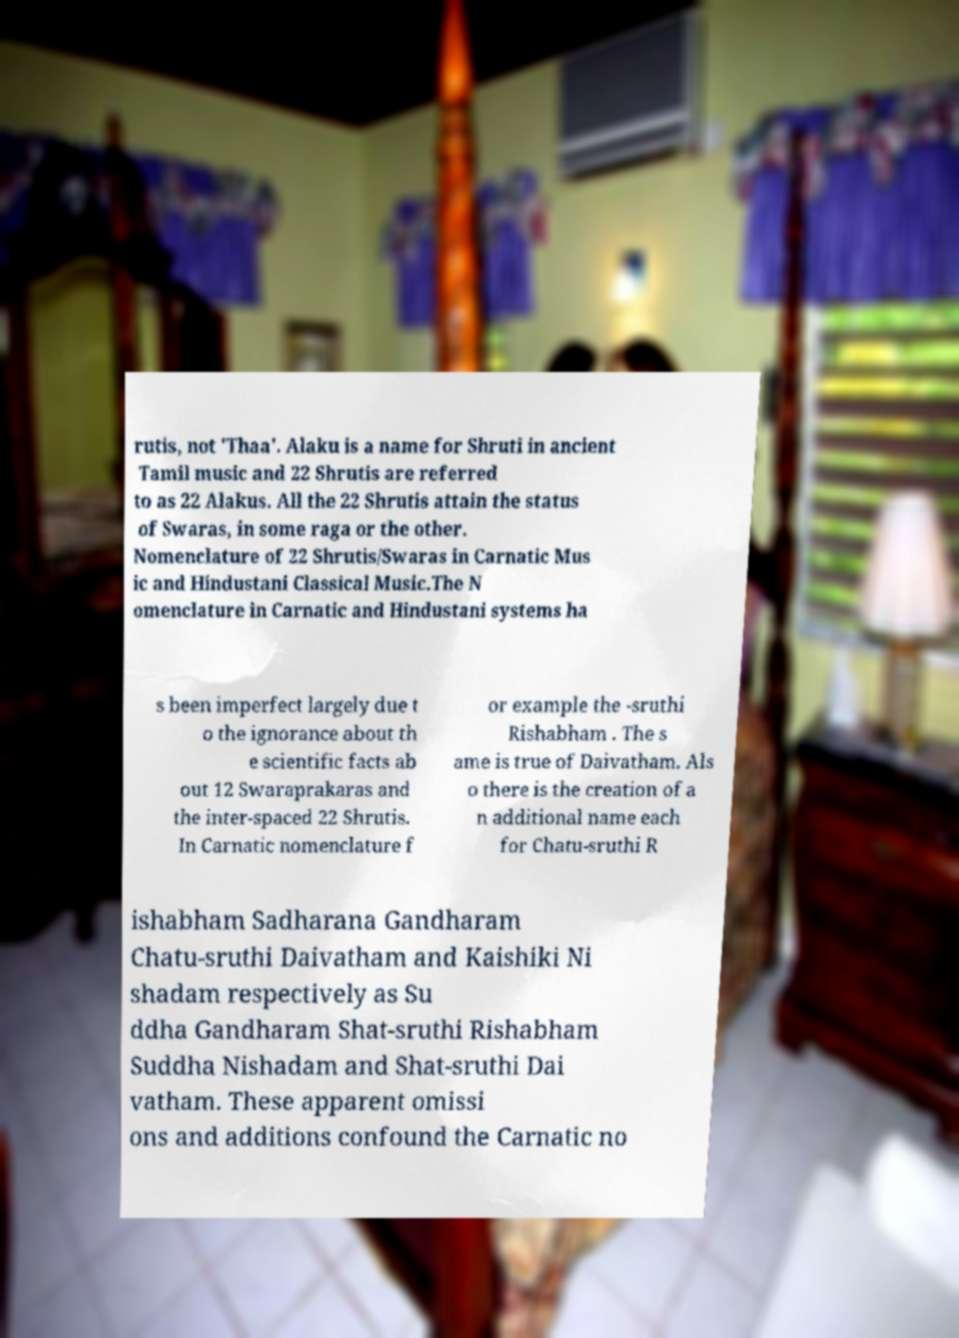Can you accurately transcribe the text from the provided image for me? rutis, not 'Thaa'. Alaku is a name for Shruti in ancient Tamil music and 22 Shrutis are referred to as 22 Alakus. All the 22 Shrutis attain the status of Swaras, in some raga or the other. Nomenclature of 22 Shrutis/Swaras in Carnatic Mus ic and Hindustani Classical Music.The N omenclature in Carnatic and Hindustani systems ha s been imperfect largely due t o the ignorance about th e scientific facts ab out 12 Swaraprakaras and the inter-spaced 22 Shrutis. In Carnatic nomenclature f or example the -sruthi Rishabham . The s ame is true of Daivatham. Als o there is the creation of a n additional name each for Chatu-sruthi R ishabham Sadharana Gandharam Chatu-sruthi Daivatham and Kaishiki Ni shadam respectively as Su ddha Gandharam Shat-sruthi Rishabham Suddha Nishadam and Shat-sruthi Dai vatham. These apparent omissi ons and additions confound the Carnatic no 